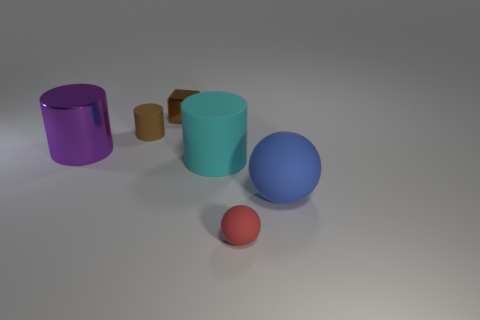Subtract all large cylinders. How many cylinders are left? 1 Subtract all yellow cylinders. Subtract all red blocks. How many cylinders are left? 3 Add 4 purple rubber cubes. How many objects exist? 10 Add 6 red metal cylinders. How many red metal cylinders exist? 6 Subtract 0 blue cubes. How many objects are left? 6 Subtract all balls. How many objects are left? 4 Subtract all large objects. Subtract all purple cylinders. How many objects are left? 2 Add 2 tiny brown metal objects. How many tiny brown metal objects are left? 3 